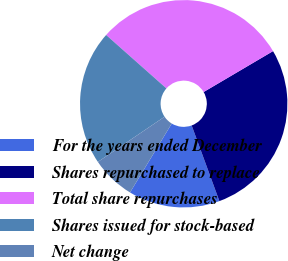<chart> <loc_0><loc_0><loc_500><loc_500><pie_chart><fcel>For the years ended December<fcel>Shares repurchased to replace<fcel>Total share repurchases<fcel>Shares issued for stock-based<fcel>Net change<nl><fcel>14.25%<fcel>27.88%<fcel>29.98%<fcel>21.02%<fcel>6.86%<nl></chart> 